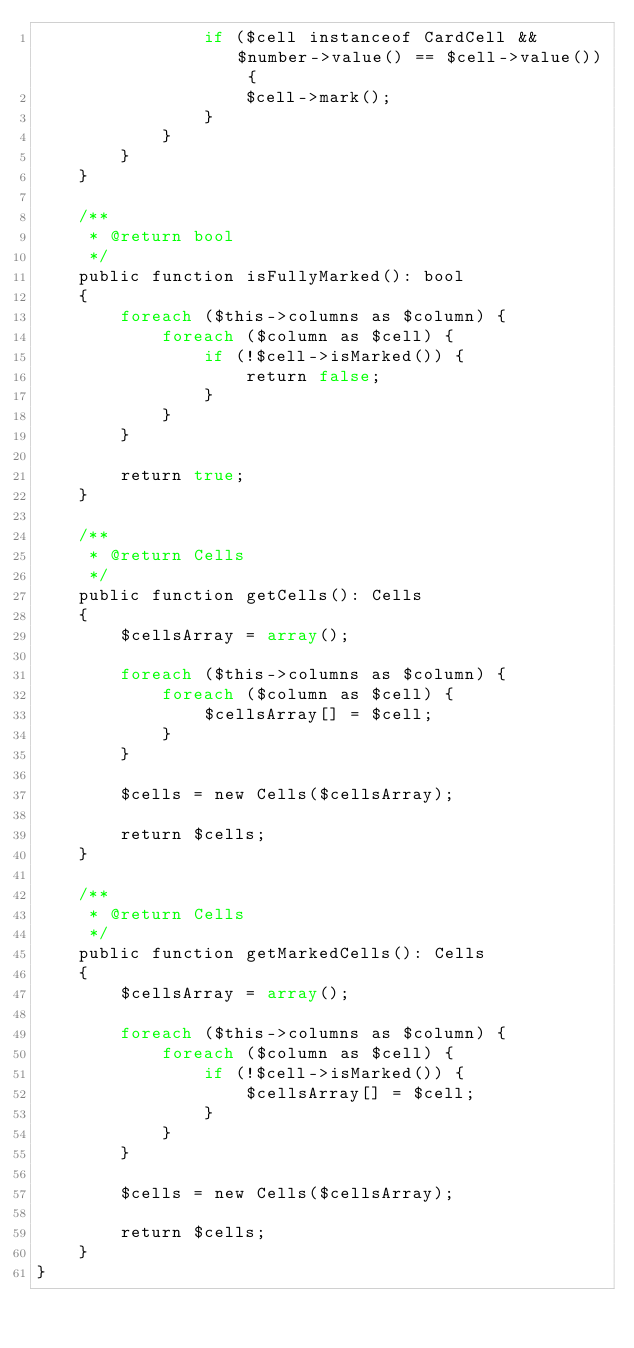<code> <loc_0><loc_0><loc_500><loc_500><_PHP_>                if ($cell instanceof CardCell && $number->value() == $cell->value()) {
                    $cell->mark();
                }
            }
        }
    }

    /**
     * @return bool
     */
    public function isFullyMarked(): bool
    {
        foreach ($this->columns as $column) {
            foreach ($column as $cell) {
                if (!$cell->isMarked()) {
                    return false;
                }
            }
        }

        return true;
    }

    /**
     * @return Cells
     */
    public function getCells(): Cells
    {
        $cellsArray = array();

        foreach ($this->columns as $column) {
            foreach ($column as $cell) {
                $cellsArray[] = $cell;
            }
        }

        $cells = new Cells($cellsArray);

        return $cells;
    }

    /**
     * @return Cells
     */
    public function getMarkedCells(): Cells
    {
        $cellsArray = array();

        foreach ($this->columns as $column) {
            foreach ($column as $cell) {
                if (!$cell->isMarked()) {
                    $cellsArray[] = $cell;
                }
            }
        }

        $cells = new Cells($cellsArray);

        return $cells;
    }
}</code> 